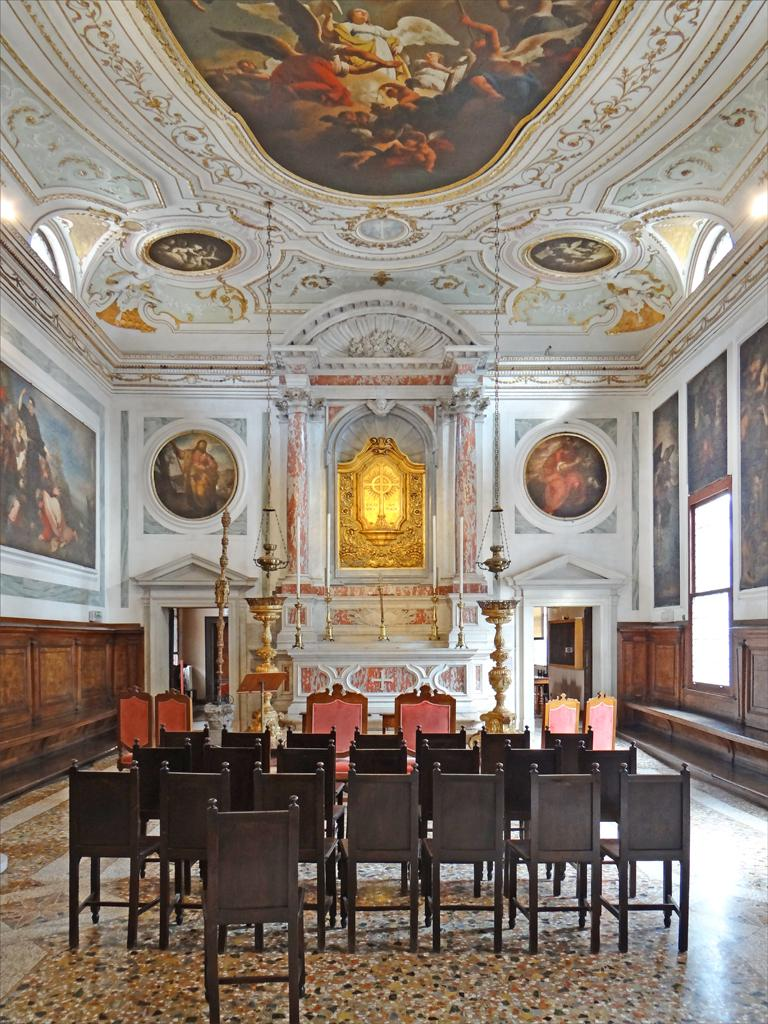What type of furniture is present in the image? There are chairs in the image. What type of artwork can be seen on the walls in the image? There are paintings on the walls in the image. Can you describe the artwork on the ceiling in the image? There are paintings on the ceiling in the image. How many ladybugs can be seen on the chairs in the image? There are no ladybugs present in the image. What type of door is visible in the image? There is no door visible in the image. 